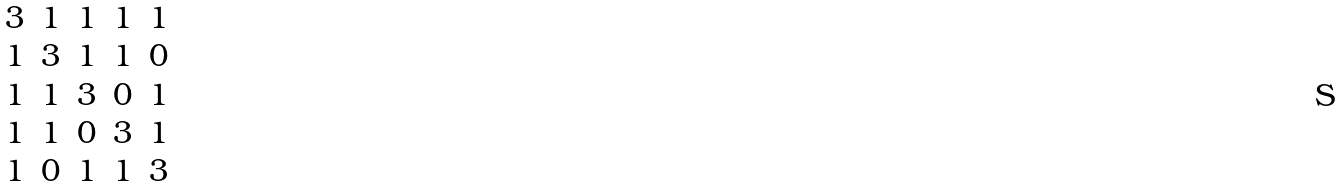<formula> <loc_0><loc_0><loc_500><loc_500>\begin{matrix} 3 & 1 & 1 & 1 & 1 \\ 1 & 3 & 1 & 1 & 0 \\ 1 & 1 & 3 & 0 & 1 \\ 1 & 1 & 0 & 3 & 1 \\ 1 & 0 & 1 & 1 & 3 \end{matrix}</formula> 